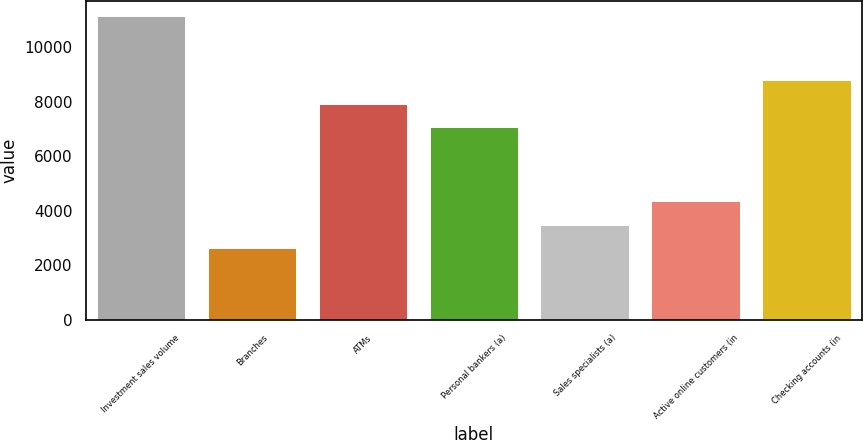<chart> <loc_0><loc_0><loc_500><loc_500><bar_chart><fcel>Investment sales volume<fcel>Branches<fcel>ATMs<fcel>Personal bankers (a)<fcel>Sales specialists (a)<fcel>Active online customers (in<fcel>Checking accounts (in<nl><fcel>11144<fcel>2641<fcel>7917.3<fcel>7067<fcel>3491.3<fcel>4341.6<fcel>8793<nl></chart> 